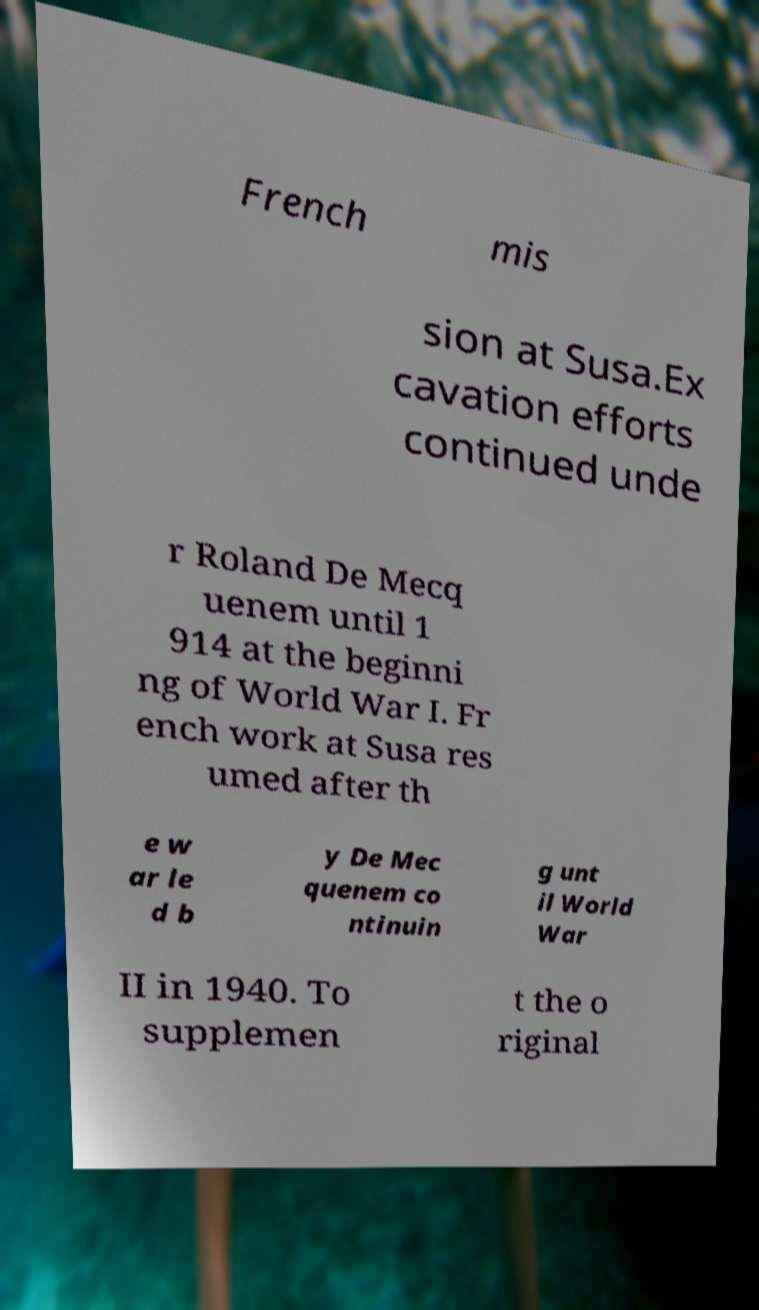Please identify and transcribe the text found in this image. French mis sion at Susa.Ex cavation efforts continued unde r Roland De Mecq uenem until 1 914 at the beginni ng of World War I. Fr ench work at Susa res umed after th e w ar le d b y De Mec quenem co ntinuin g unt il World War II in 1940. To supplemen t the o riginal 